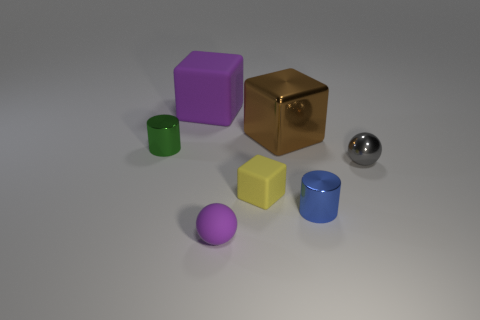Subtract all metallic cubes. How many cubes are left? 2 Subtract all brown blocks. How many blocks are left? 2 Subtract all balls. How many objects are left? 5 Add 3 yellow matte blocks. How many objects exist? 10 Subtract all purple cubes. How many yellow cylinders are left? 0 Subtract all tiny cyan shiny cylinders. Subtract all blue objects. How many objects are left? 6 Add 6 tiny yellow cubes. How many tiny yellow cubes are left? 7 Add 6 small rubber blocks. How many small rubber blocks exist? 7 Subtract 0 red spheres. How many objects are left? 7 Subtract 1 cylinders. How many cylinders are left? 1 